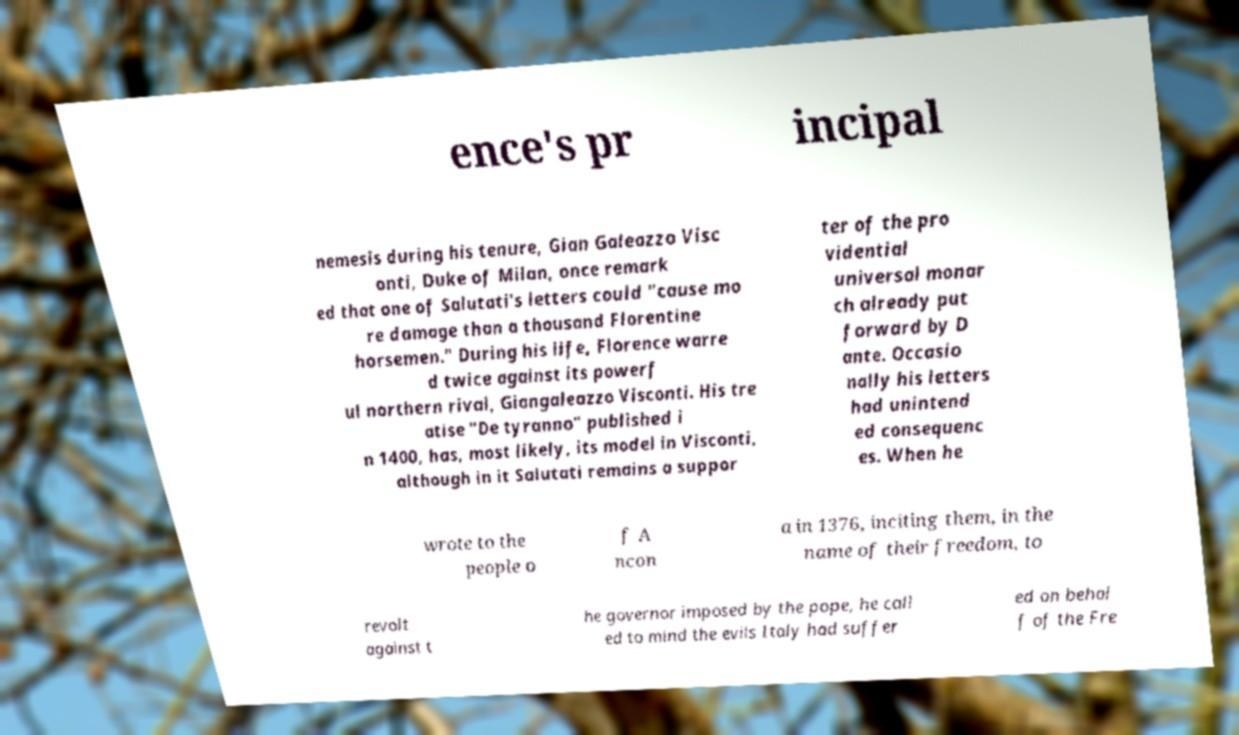Can you read and provide the text displayed in the image?This photo seems to have some interesting text. Can you extract and type it out for me? ence's pr incipal nemesis during his tenure, Gian Galeazzo Visc onti, Duke of Milan, once remark ed that one of Salutati's letters could "cause mo re damage than a thousand Florentine horsemen." During his life, Florence warre d twice against its powerf ul northern rival, Giangaleazzo Visconti. His tre atise "De tyranno" published i n 1400, has, most likely, its model in Visconti, although in it Salutati remains a suppor ter of the pro vidential universal monar ch already put forward by D ante. Occasio nally his letters had unintend ed consequenc es. When he wrote to the people o f A ncon a in 1376, inciting them, in the name of their freedom, to revolt against t he governor imposed by the pope, he call ed to mind the evils Italy had suffer ed on behal f of the Fre 